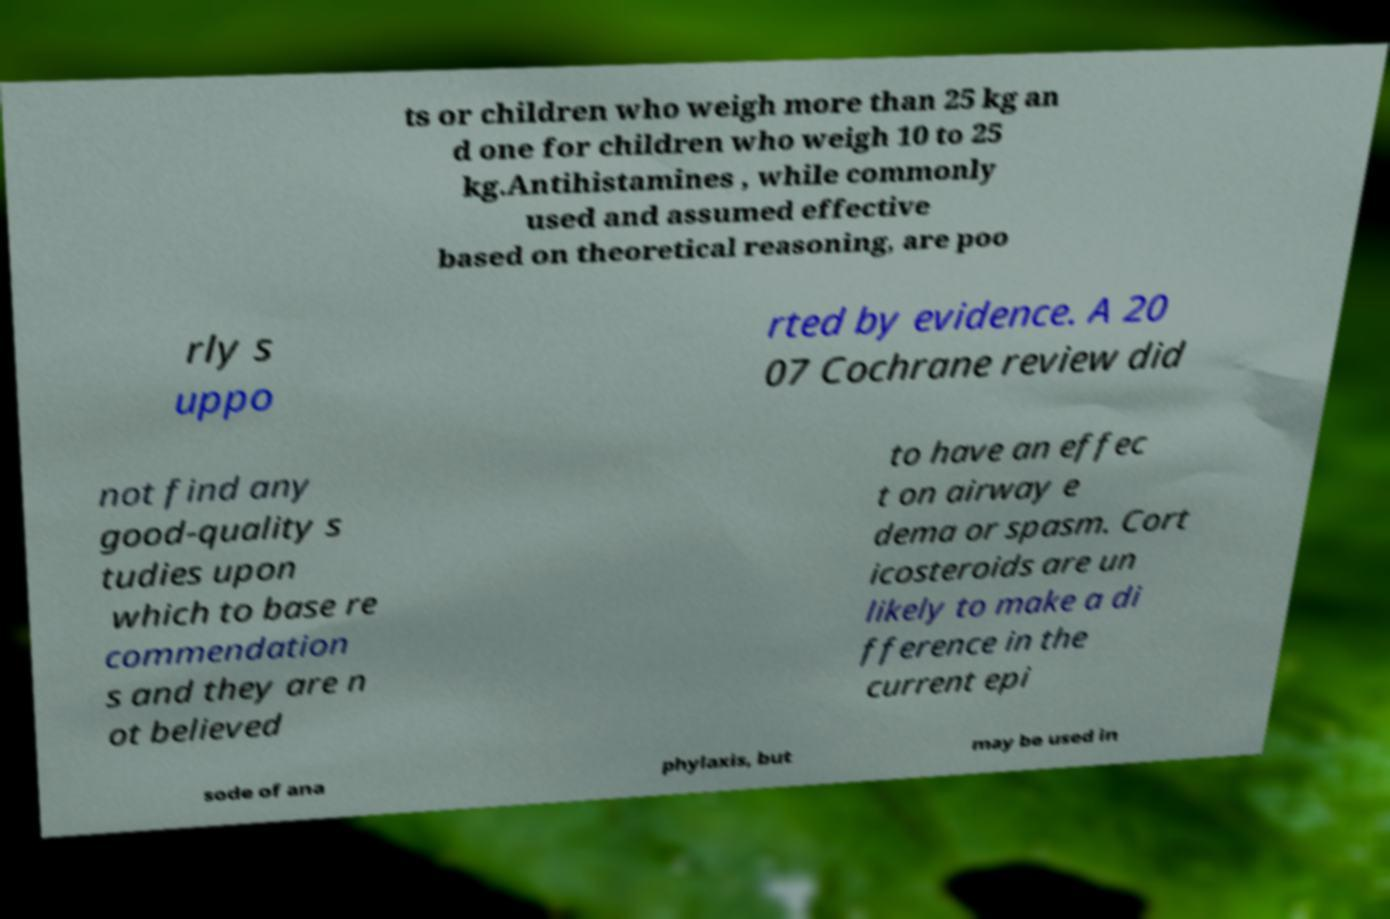For documentation purposes, I need the text within this image transcribed. Could you provide that? ts or children who weigh more than 25 kg an d one for children who weigh 10 to 25 kg.Antihistamines , while commonly used and assumed effective based on theoretical reasoning, are poo rly s uppo rted by evidence. A 20 07 Cochrane review did not find any good-quality s tudies upon which to base re commendation s and they are n ot believed to have an effec t on airway e dema or spasm. Cort icosteroids are un likely to make a di fference in the current epi sode of ana phylaxis, but may be used in 